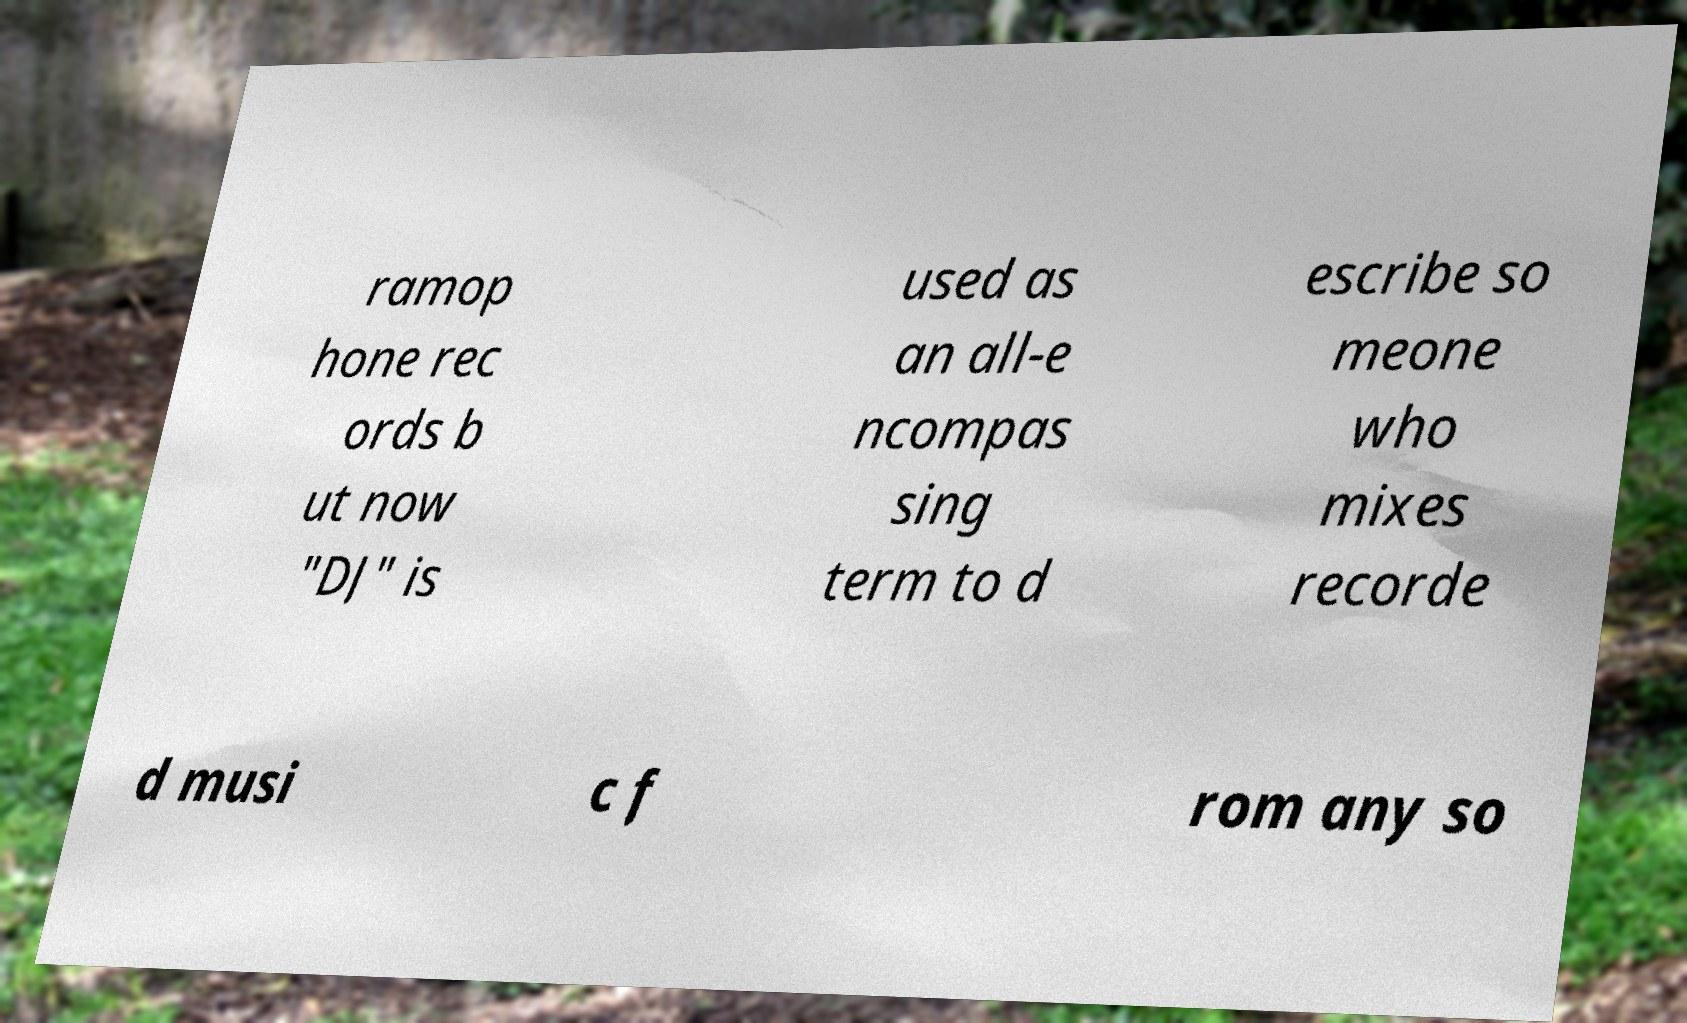What messages or text are displayed in this image? I need them in a readable, typed format. ramop hone rec ords b ut now "DJ" is used as an all-e ncompas sing term to d escribe so meone who mixes recorde d musi c f rom any so 